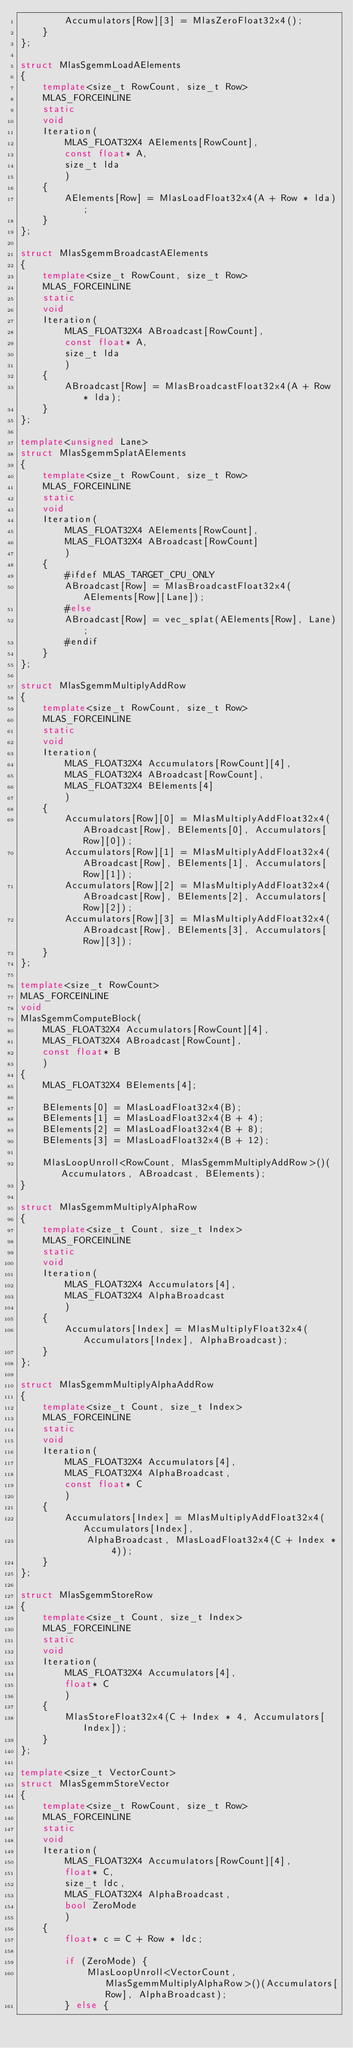Convert code to text. <code><loc_0><loc_0><loc_500><loc_500><_C++_>        Accumulators[Row][3] = MlasZeroFloat32x4();
    }
};

struct MlasSgemmLoadAElements
{
    template<size_t RowCount, size_t Row>
    MLAS_FORCEINLINE
    static
    void
    Iteration(
        MLAS_FLOAT32X4 AElements[RowCount],
        const float* A,
        size_t lda
        )
    {
        AElements[Row] = MlasLoadFloat32x4(A + Row * lda);
    }
};

struct MlasSgemmBroadcastAElements
{
    template<size_t RowCount, size_t Row>
    MLAS_FORCEINLINE
    static
    void
    Iteration(
        MLAS_FLOAT32X4 ABroadcast[RowCount],
        const float* A,
        size_t lda
        )
    {
        ABroadcast[Row] = MlasBroadcastFloat32x4(A + Row * lda);
    }
};

template<unsigned Lane>
struct MlasSgemmSplatAElements
{
    template<size_t RowCount, size_t Row>
    MLAS_FORCEINLINE
    static
    void
    Iteration(
        MLAS_FLOAT32X4 AElements[RowCount],
        MLAS_FLOAT32X4 ABroadcast[RowCount]
        )
    {
        #ifdef MLAS_TARGET_CPU_ONLY
        ABroadcast[Row] = MlasBroadcastFloat32x4(AElements[Row][Lane]);
        #else
        ABroadcast[Row] = vec_splat(AElements[Row], Lane);
        #endif
    }
};

struct MlasSgemmMultiplyAddRow
{
    template<size_t RowCount, size_t Row>
    MLAS_FORCEINLINE
    static
    void
    Iteration(
        MLAS_FLOAT32X4 Accumulators[RowCount][4],
        MLAS_FLOAT32X4 ABroadcast[RowCount],
        MLAS_FLOAT32X4 BElements[4]
        )
    {
        Accumulators[Row][0] = MlasMultiplyAddFloat32x4(ABroadcast[Row], BElements[0], Accumulators[Row][0]);
        Accumulators[Row][1] = MlasMultiplyAddFloat32x4(ABroadcast[Row], BElements[1], Accumulators[Row][1]);
        Accumulators[Row][2] = MlasMultiplyAddFloat32x4(ABroadcast[Row], BElements[2], Accumulators[Row][2]);
        Accumulators[Row][3] = MlasMultiplyAddFloat32x4(ABroadcast[Row], BElements[3], Accumulators[Row][3]);
    }
};

template<size_t RowCount>
MLAS_FORCEINLINE
void
MlasSgemmComputeBlock(
    MLAS_FLOAT32X4 Accumulators[RowCount][4],
    MLAS_FLOAT32X4 ABroadcast[RowCount],
    const float* B
    )
{
    MLAS_FLOAT32X4 BElements[4];

    BElements[0] = MlasLoadFloat32x4(B);
    BElements[1] = MlasLoadFloat32x4(B + 4);
    BElements[2] = MlasLoadFloat32x4(B + 8);
    BElements[3] = MlasLoadFloat32x4(B + 12);

    MlasLoopUnroll<RowCount, MlasSgemmMultiplyAddRow>()(Accumulators, ABroadcast, BElements);
}

struct MlasSgemmMultiplyAlphaRow
{
    template<size_t Count, size_t Index>
    MLAS_FORCEINLINE
    static
    void
    Iteration(
        MLAS_FLOAT32X4 Accumulators[4],
        MLAS_FLOAT32X4 AlphaBroadcast
        )
    {
        Accumulators[Index] = MlasMultiplyFloat32x4(Accumulators[Index], AlphaBroadcast);
    }
};

struct MlasSgemmMultiplyAlphaAddRow
{
    template<size_t Count, size_t Index>
    MLAS_FORCEINLINE
    static
    void
    Iteration(
        MLAS_FLOAT32X4 Accumulators[4],
        MLAS_FLOAT32X4 AlphaBroadcast,
        const float* C
        )
    {
        Accumulators[Index] = MlasMultiplyAddFloat32x4(Accumulators[Index],
            AlphaBroadcast, MlasLoadFloat32x4(C + Index * 4));
    }
};

struct MlasSgemmStoreRow
{
    template<size_t Count, size_t Index>
    MLAS_FORCEINLINE
    static
    void
    Iteration(
        MLAS_FLOAT32X4 Accumulators[4],
        float* C
        )
    {
        MlasStoreFloat32x4(C + Index * 4, Accumulators[Index]);
    }
};

template<size_t VectorCount>
struct MlasSgemmStoreVector
{
    template<size_t RowCount, size_t Row>
    MLAS_FORCEINLINE
    static
    void
    Iteration(
        MLAS_FLOAT32X4 Accumulators[RowCount][4],
        float* C,
        size_t ldc,
        MLAS_FLOAT32X4 AlphaBroadcast,
        bool ZeroMode
        )
    {
        float* c = C + Row * ldc;

        if (ZeroMode) {
            MlasLoopUnroll<VectorCount, MlasSgemmMultiplyAlphaRow>()(Accumulators[Row], AlphaBroadcast);
        } else {</code> 